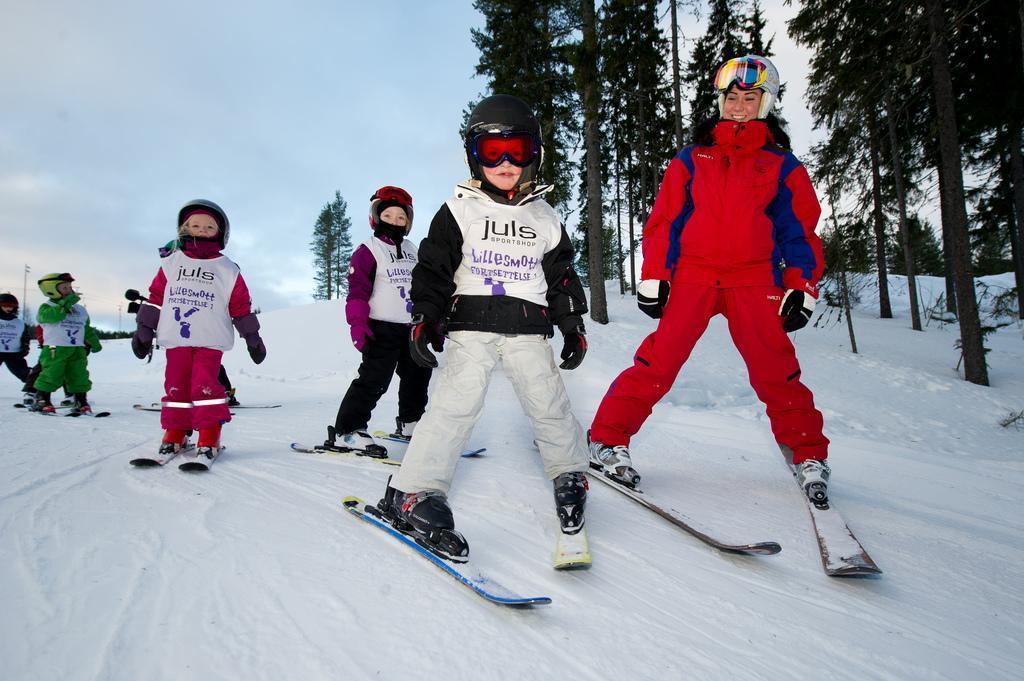How many adults are there?
Give a very brief answer. 1. How many adults are in the picture?
Give a very brief answer. 1. 